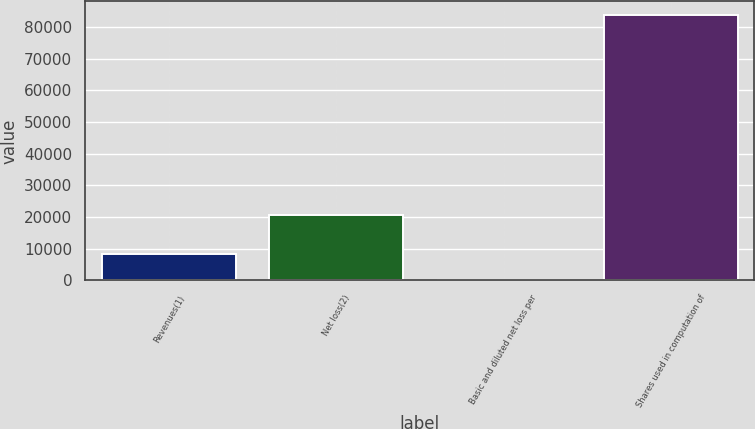Convert chart. <chart><loc_0><loc_0><loc_500><loc_500><bar_chart><fcel>Revenues(1)<fcel>Net loss(2)<fcel>Basic and diluted net loss per<fcel>Shares used in computation of<nl><fcel>8393.32<fcel>20502<fcel>0.24<fcel>83931<nl></chart> 